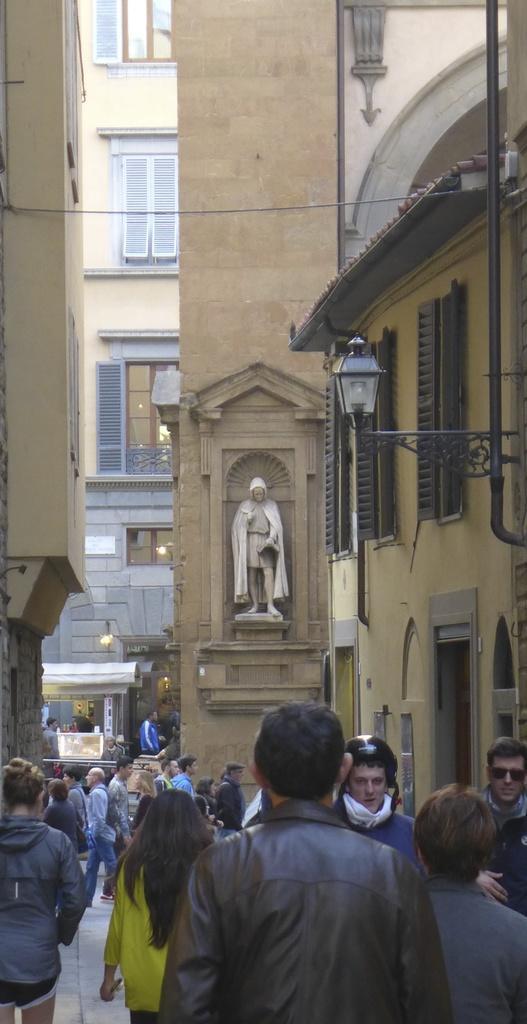Please provide a concise description of this image. In this image we can see there are so many people walking on the road, beside them there are buildings and also a big pillar with persons sculpture. 